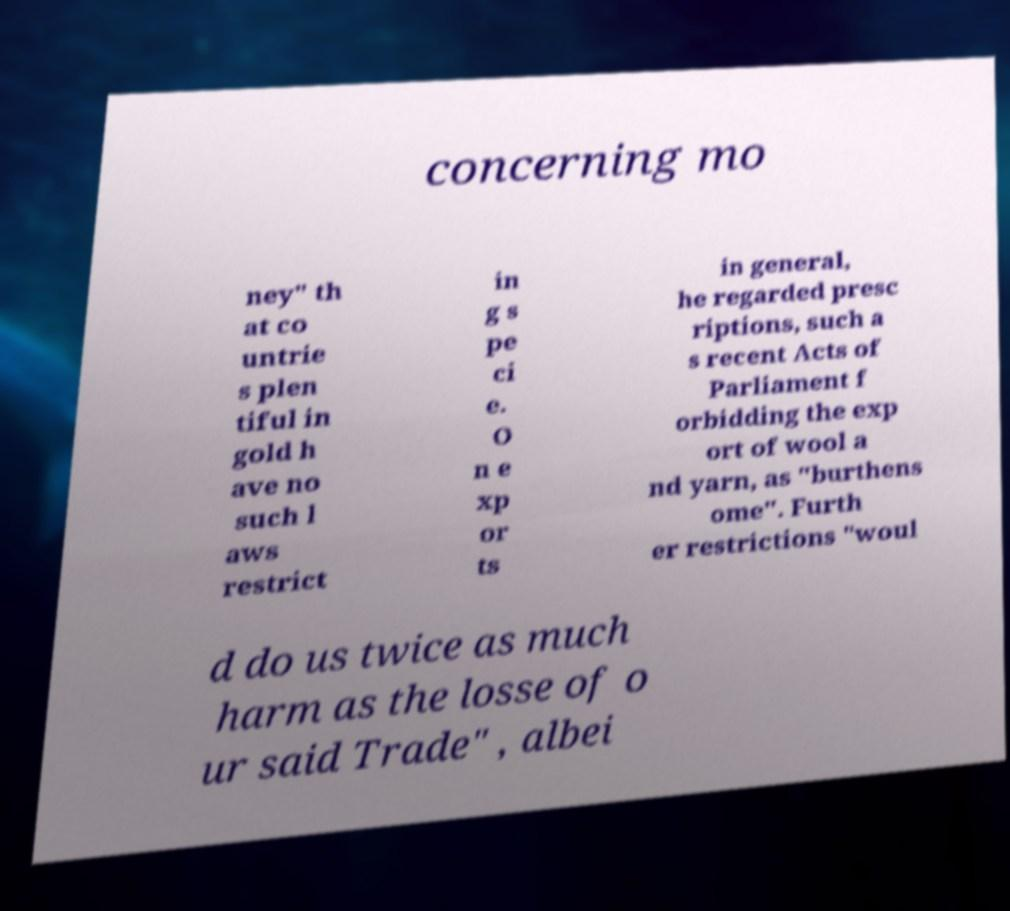Can you read and provide the text displayed in the image?This photo seems to have some interesting text. Can you extract and type it out for me? concerning mo ney" th at co untrie s plen tiful in gold h ave no such l aws restrict in g s pe ci e. O n e xp or ts in general, he regarded presc riptions, such a s recent Acts of Parliament f orbidding the exp ort of wool a nd yarn, as "burthens ome". Furth er restrictions "woul d do us twice as much harm as the losse of o ur said Trade" , albei 